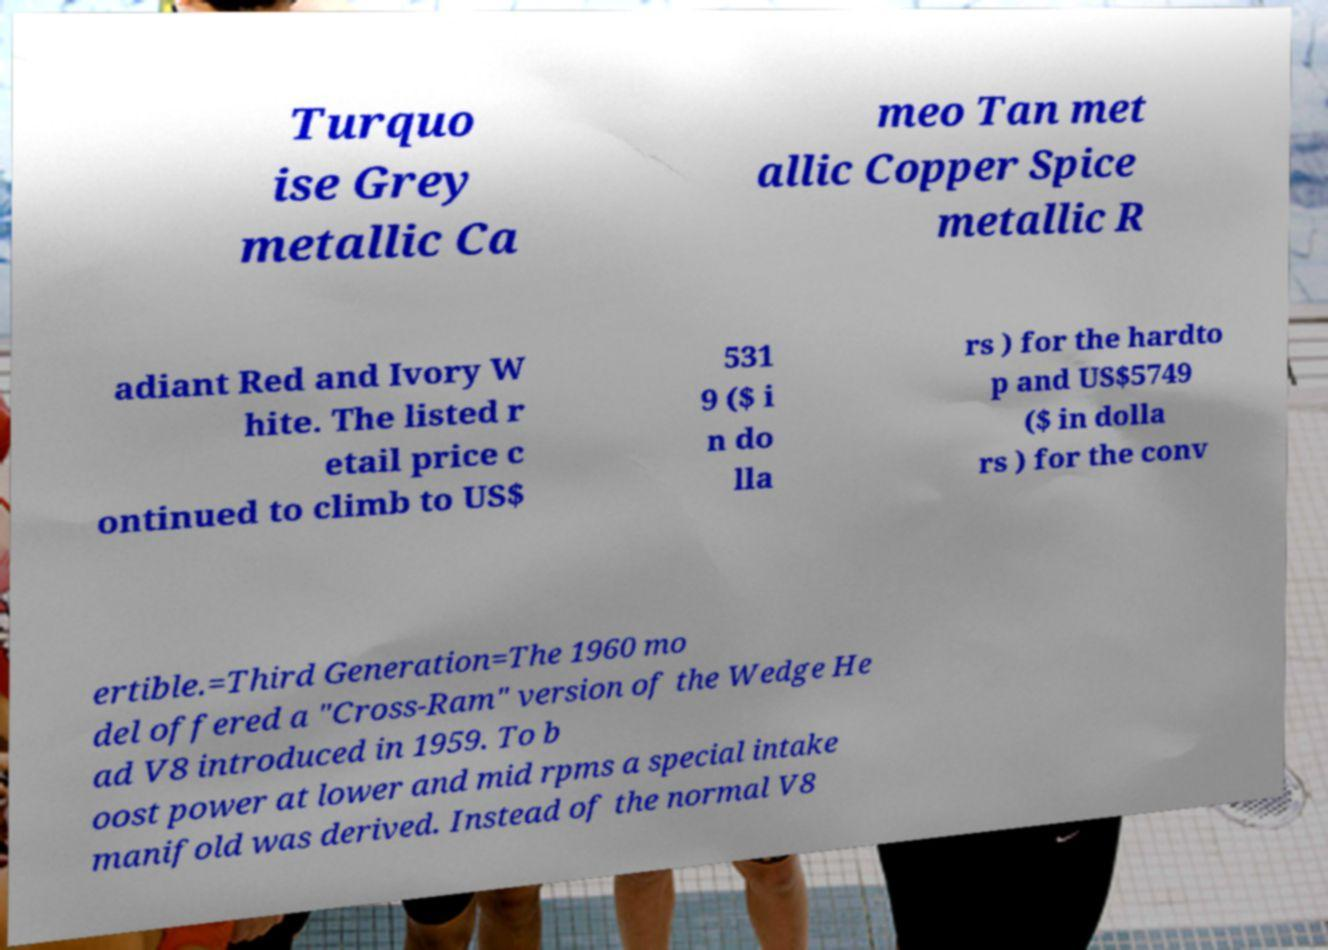Can you accurately transcribe the text from the provided image for me? Turquo ise Grey metallic Ca meo Tan met allic Copper Spice metallic R adiant Red and Ivory W hite. The listed r etail price c ontinued to climb to US$ 531 9 ($ i n do lla rs ) for the hardto p and US$5749 ($ in dolla rs ) for the conv ertible.=Third Generation=The 1960 mo del offered a "Cross-Ram" version of the Wedge He ad V8 introduced in 1959. To b oost power at lower and mid rpms a special intake manifold was derived. Instead of the normal V8 